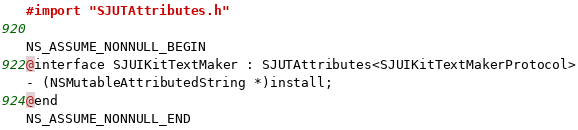Convert code to text. <code><loc_0><loc_0><loc_500><loc_500><_C_>
#import "SJUTAttributes.h"

NS_ASSUME_NONNULL_BEGIN
@interface SJUIKitTextMaker : SJUTAttributes<SJUIKitTextMakerProtocol>
- (NSMutableAttributedString *)install;
@end
NS_ASSUME_NONNULL_END
</code> 